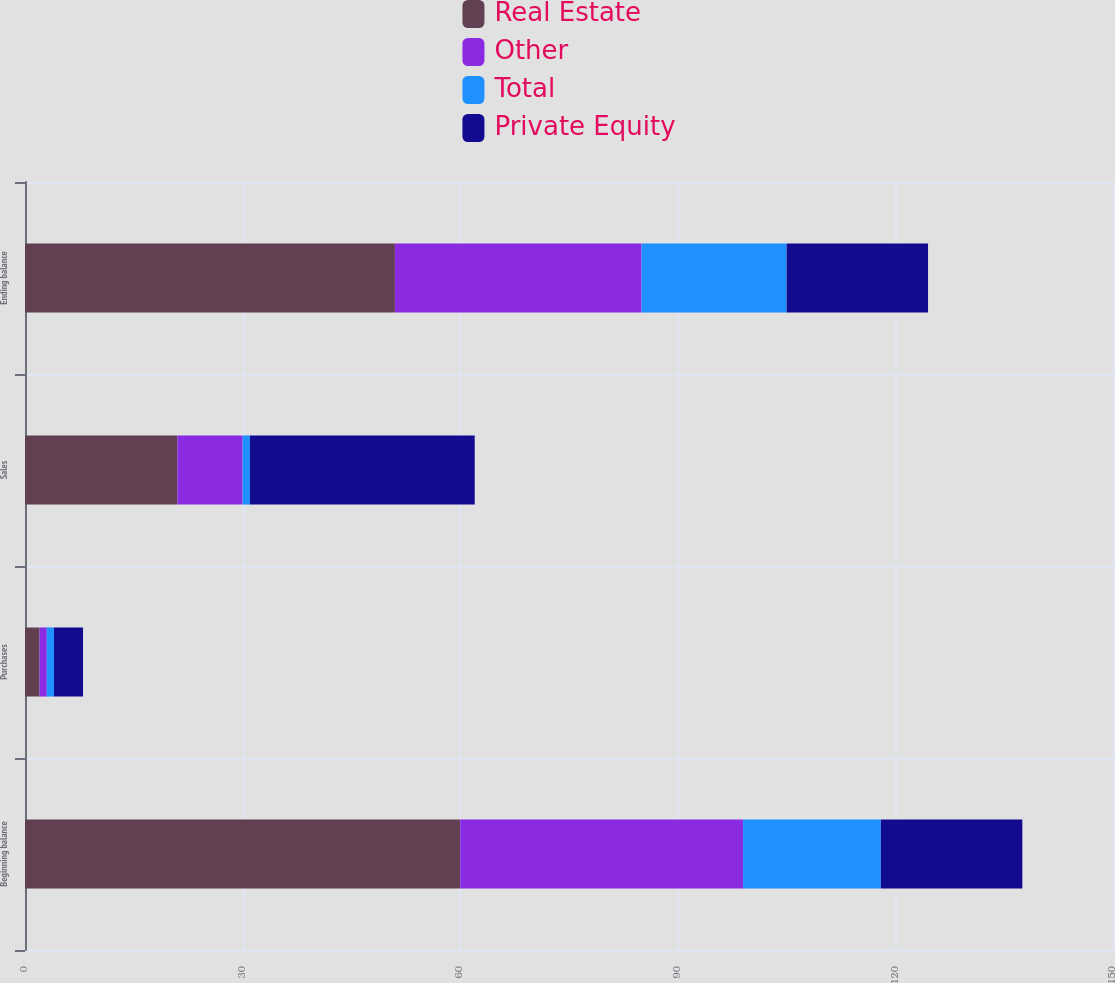Convert chart to OTSL. <chart><loc_0><loc_0><loc_500><loc_500><stacked_bar_chart><ecel><fcel>Beginning balance<fcel>Purchases<fcel>Sales<fcel>Ending balance<nl><fcel>Real Estate<fcel>60<fcel>2<fcel>21<fcel>51<nl><fcel>Other<fcel>39<fcel>1<fcel>9<fcel>34<nl><fcel>Total<fcel>19<fcel>1<fcel>1<fcel>20<nl><fcel>Private Equity<fcel>19.5<fcel>4<fcel>31<fcel>19.5<nl></chart> 